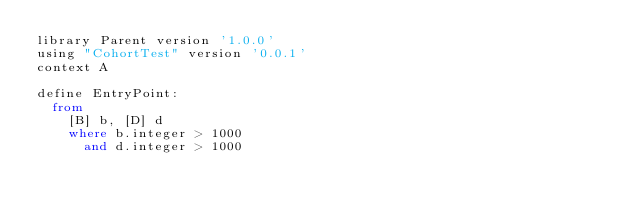<code> <loc_0><loc_0><loc_500><loc_500><_SQL_>library Parent version '1.0.0'
using "CohortTest" version '0.0.1'
context A

define EntryPoint:
  from
    [B] b, [D] d
    where b.integer > 1000
      and d.integer > 1000
</code> 